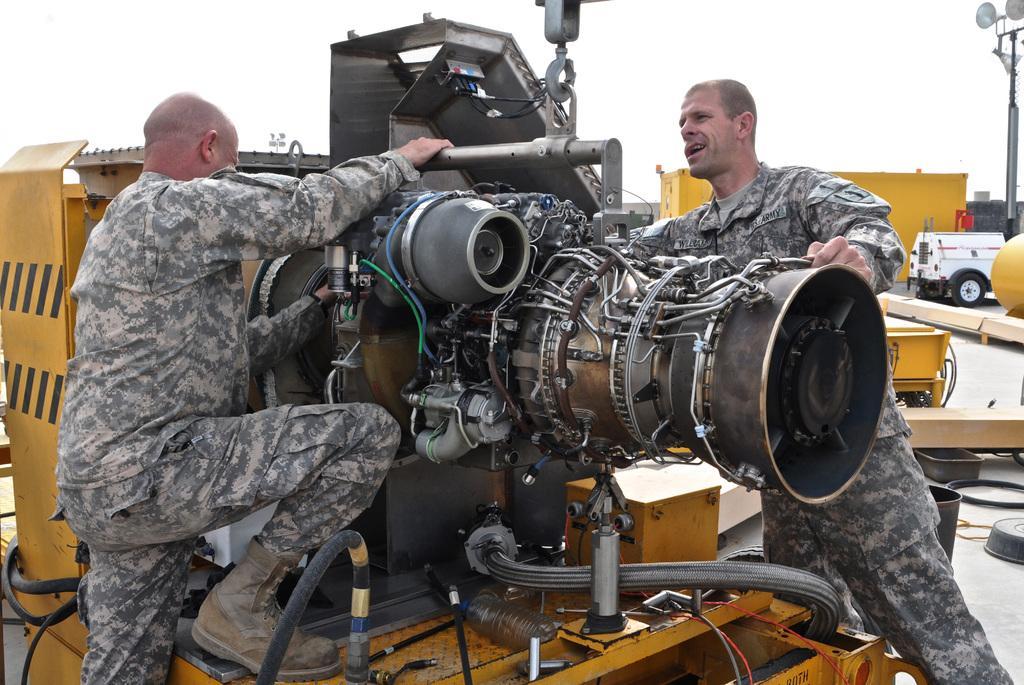Can you describe this image briefly? In this image we can see two persons standing near to a machine. On the machine there are wires, rods, hook and some other things. In the back there is a vehicle and a pole on the right side. 